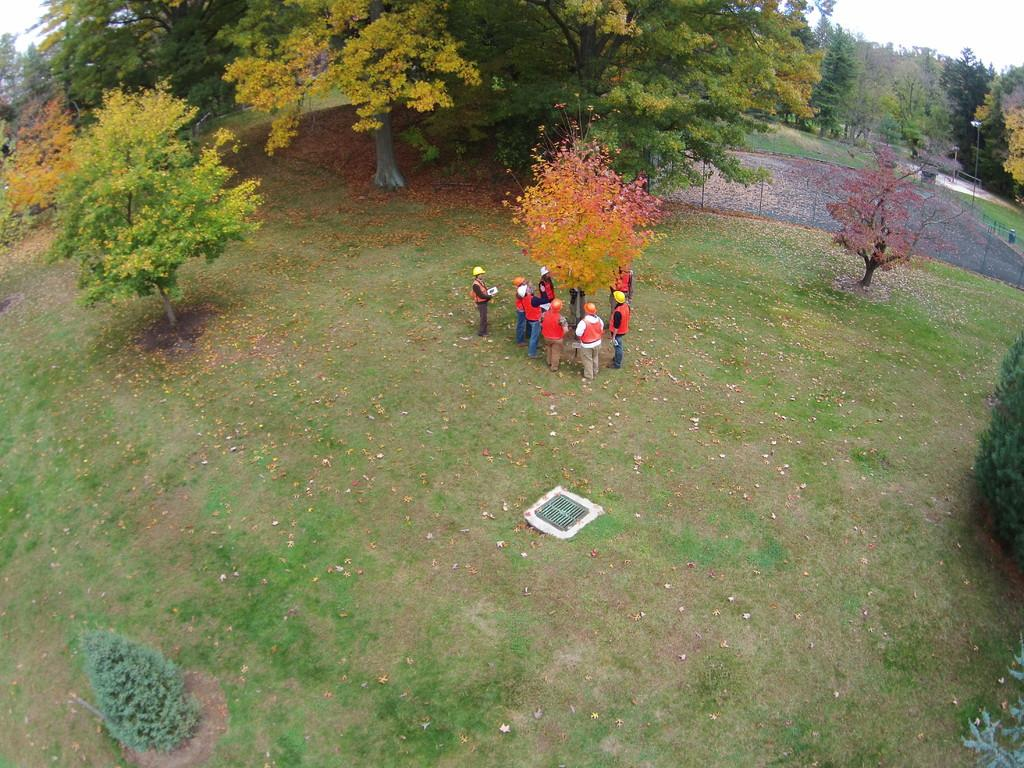What are the people in the image doing? The people in the image are standing on the ground in the middle of the image. What type of vegetation can be seen in the image? There are trees and grass in the image. What is visible in the background of the image? The sky is visible in the background of the image. What type of cord is being used by the representative in the image? There is no representative or cord present in the image. 